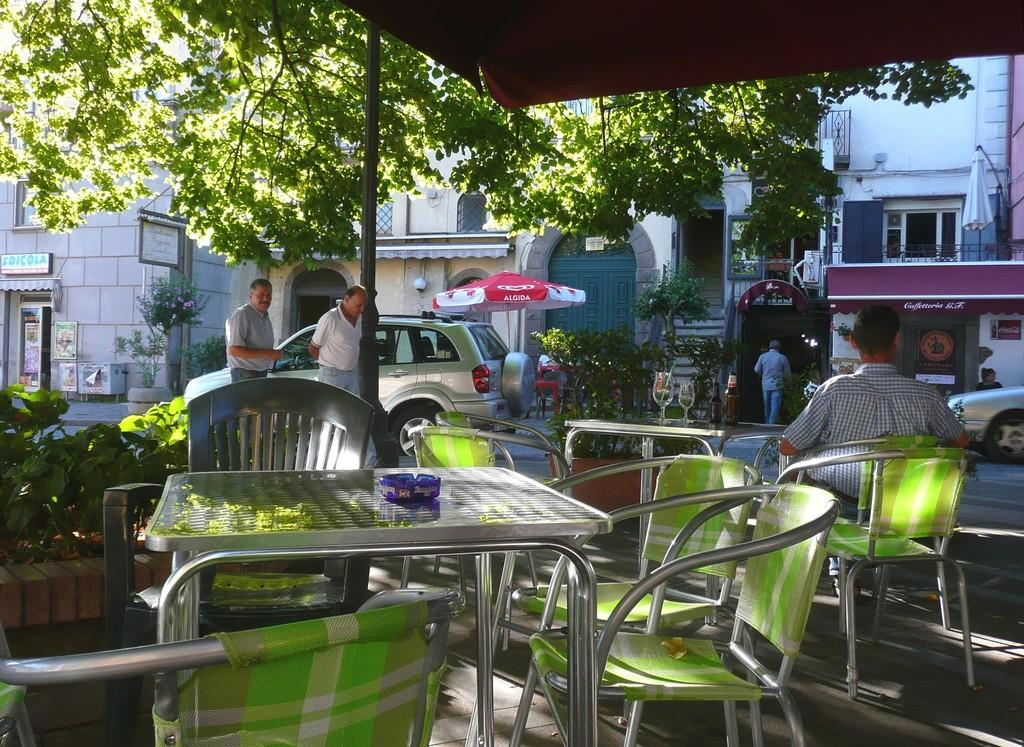What type of furniture is present in the image? There are chairs and tables in the image. How many glasses can be seen in the image? There are two glasses in the image. What is the primary activity of the people in the image? The presence of chairs, tables, and glasses suggests that the people in the image might be dining or socializing. What can be seen in the background of the image? There are buildings and a tree in the background of the image. What else is present in the image besides furniture and people? There are vehicles in the image. What idea does the kitty have about the sense of humor in the image? There is no kitty present in the image, so it is not possible to determine its ideas or sense of humor. 